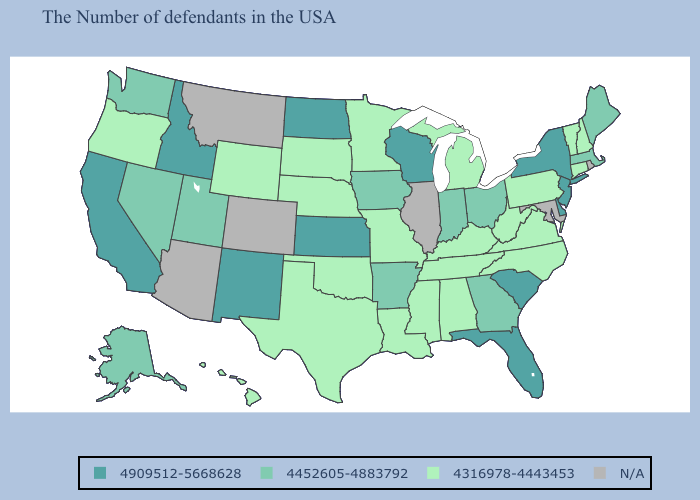What is the value of Arizona?
Keep it brief. N/A. What is the lowest value in states that border New Mexico?
Answer briefly. 4316978-4443453. Does Utah have the lowest value in the USA?
Keep it brief. No. Name the states that have a value in the range 4909512-5668628?
Short answer required. New York, New Jersey, Delaware, South Carolina, Florida, Wisconsin, Kansas, North Dakota, New Mexico, Idaho, California. Which states have the lowest value in the West?
Keep it brief. Wyoming, Oregon, Hawaii. What is the value of Colorado?
Give a very brief answer. N/A. Name the states that have a value in the range N/A?
Write a very short answer. Rhode Island, Maryland, Illinois, Colorado, Montana, Arizona. Name the states that have a value in the range 4316978-4443453?
Keep it brief. New Hampshire, Vermont, Connecticut, Pennsylvania, Virginia, North Carolina, West Virginia, Michigan, Kentucky, Alabama, Tennessee, Mississippi, Louisiana, Missouri, Minnesota, Nebraska, Oklahoma, Texas, South Dakota, Wyoming, Oregon, Hawaii. Name the states that have a value in the range 4909512-5668628?
Quick response, please. New York, New Jersey, Delaware, South Carolina, Florida, Wisconsin, Kansas, North Dakota, New Mexico, Idaho, California. Name the states that have a value in the range 4909512-5668628?
Short answer required. New York, New Jersey, Delaware, South Carolina, Florida, Wisconsin, Kansas, North Dakota, New Mexico, Idaho, California. Does Connecticut have the lowest value in the Northeast?
Keep it brief. Yes. Name the states that have a value in the range 4316978-4443453?
Short answer required. New Hampshire, Vermont, Connecticut, Pennsylvania, Virginia, North Carolina, West Virginia, Michigan, Kentucky, Alabama, Tennessee, Mississippi, Louisiana, Missouri, Minnesota, Nebraska, Oklahoma, Texas, South Dakota, Wyoming, Oregon, Hawaii. Name the states that have a value in the range 4452605-4883792?
Write a very short answer. Maine, Massachusetts, Ohio, Georgia, Indiana, Arkansas, Iowa, Utah, Nevada, Washington, Alaska. Among the states that border Idaho , which have the highest value?
Answer briefly. Utah, Nevada, Washington. What is the highest value in the USA?
Give a very brief answer. 4909512-5668628. 